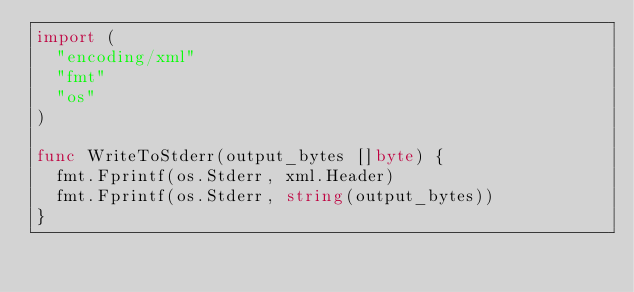Convert code to text. <code><loc_0><loc_0><loc_500><loc_500><_Go_>import (
  "encoding/xml"
  "fmt"
  "os"
)

func WriteToStderr(output_bytes []byte) {
  fmt.Fprintf(os.Stderr, xml.Header)
  fmt.Fprintf(os.Stderr, string(output_bytes))
}
</code> 